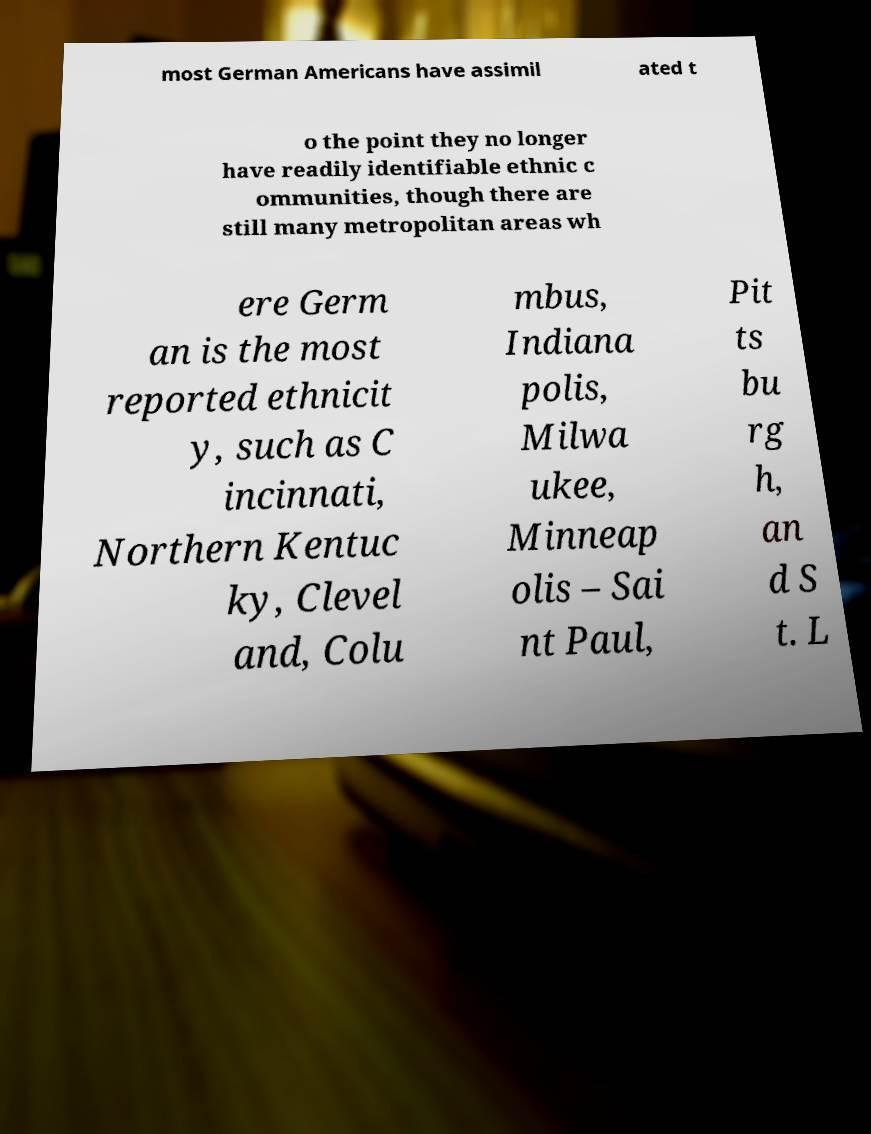Can you accurately transcribe the text from the provided image for me? most German Americans have assimil ated t o the point they no longer have readily identifiable ethnic c ommunities, though there are still many metropolitan areas wh ere Germ an is the most reported ethnicit y, such as C incinnati, Northern Kentuc ky, Clevel and, Colu mbus, Indiana polis, Milwa ukee, Minneap olis – Sai nt Paul, Pit ts bu rg h, an d S t. L 